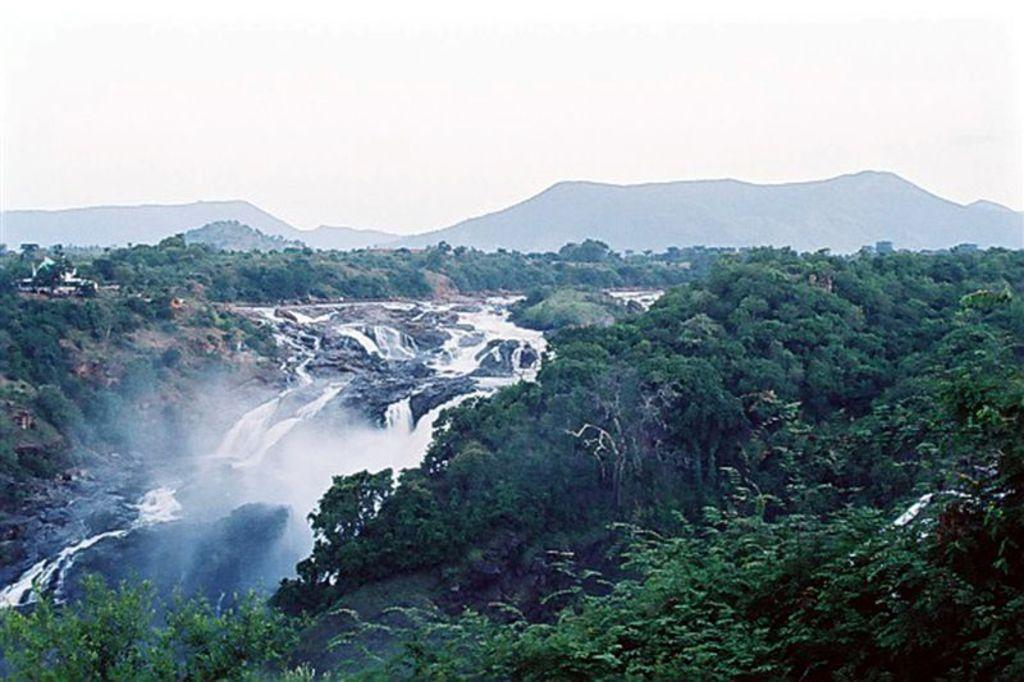What type of natural features can be seen in the image? There are trees and hills in the image. What other natural feature is present in the image? There is a waterfall in the image. What can be seen in the background of the image? The sky is visible in the background of the image. Where is the chair located in the image? There is no chair present in the image. What type of cord can be seen connecting the trees in the image? There is no cord connecting the trees in the image; it only features natural elements. 